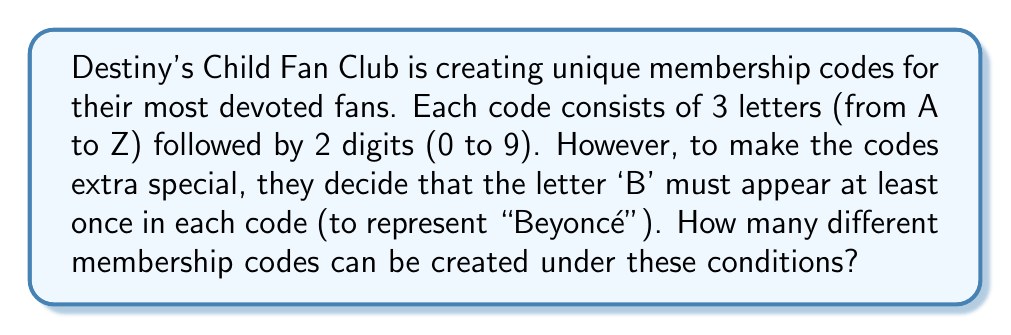What is the answer to this math problem? Let's approach this step-by-step:

1) First, let's consider the total number of codes without the 'B' restriction:
   - 3 letters: $26^3$ choices
   - 2 digits: $10^2$ choices
   Total: $26^3 \times 10^2$

2) Now, we need to subtract the number of codes that don't contain 'B':
   - 3 letters (excluding 'B'): $25^3$ choices
   - 2 digits: $10^2$ choices
   Codes without 'B': $25^3 \times 10^2$

3) Therefore, the number of valid codes is:
   $$(26^3 \times 10^2) - (25^3 \times 10^2)$$

4) Let's calculate:
   $$\begin{align}
   &(26^3 \times 10^2) - (25^3 \times 10^2) \\
   &= (17576 \times 100) - (15625 \times 100) \\
   &= 1757600 - 1562500 \\
   &= 195100
   \end{align}$$

Thus, there are 195,100 possible unique membership codes that include at least one 'B'.
Answer: 195,100 